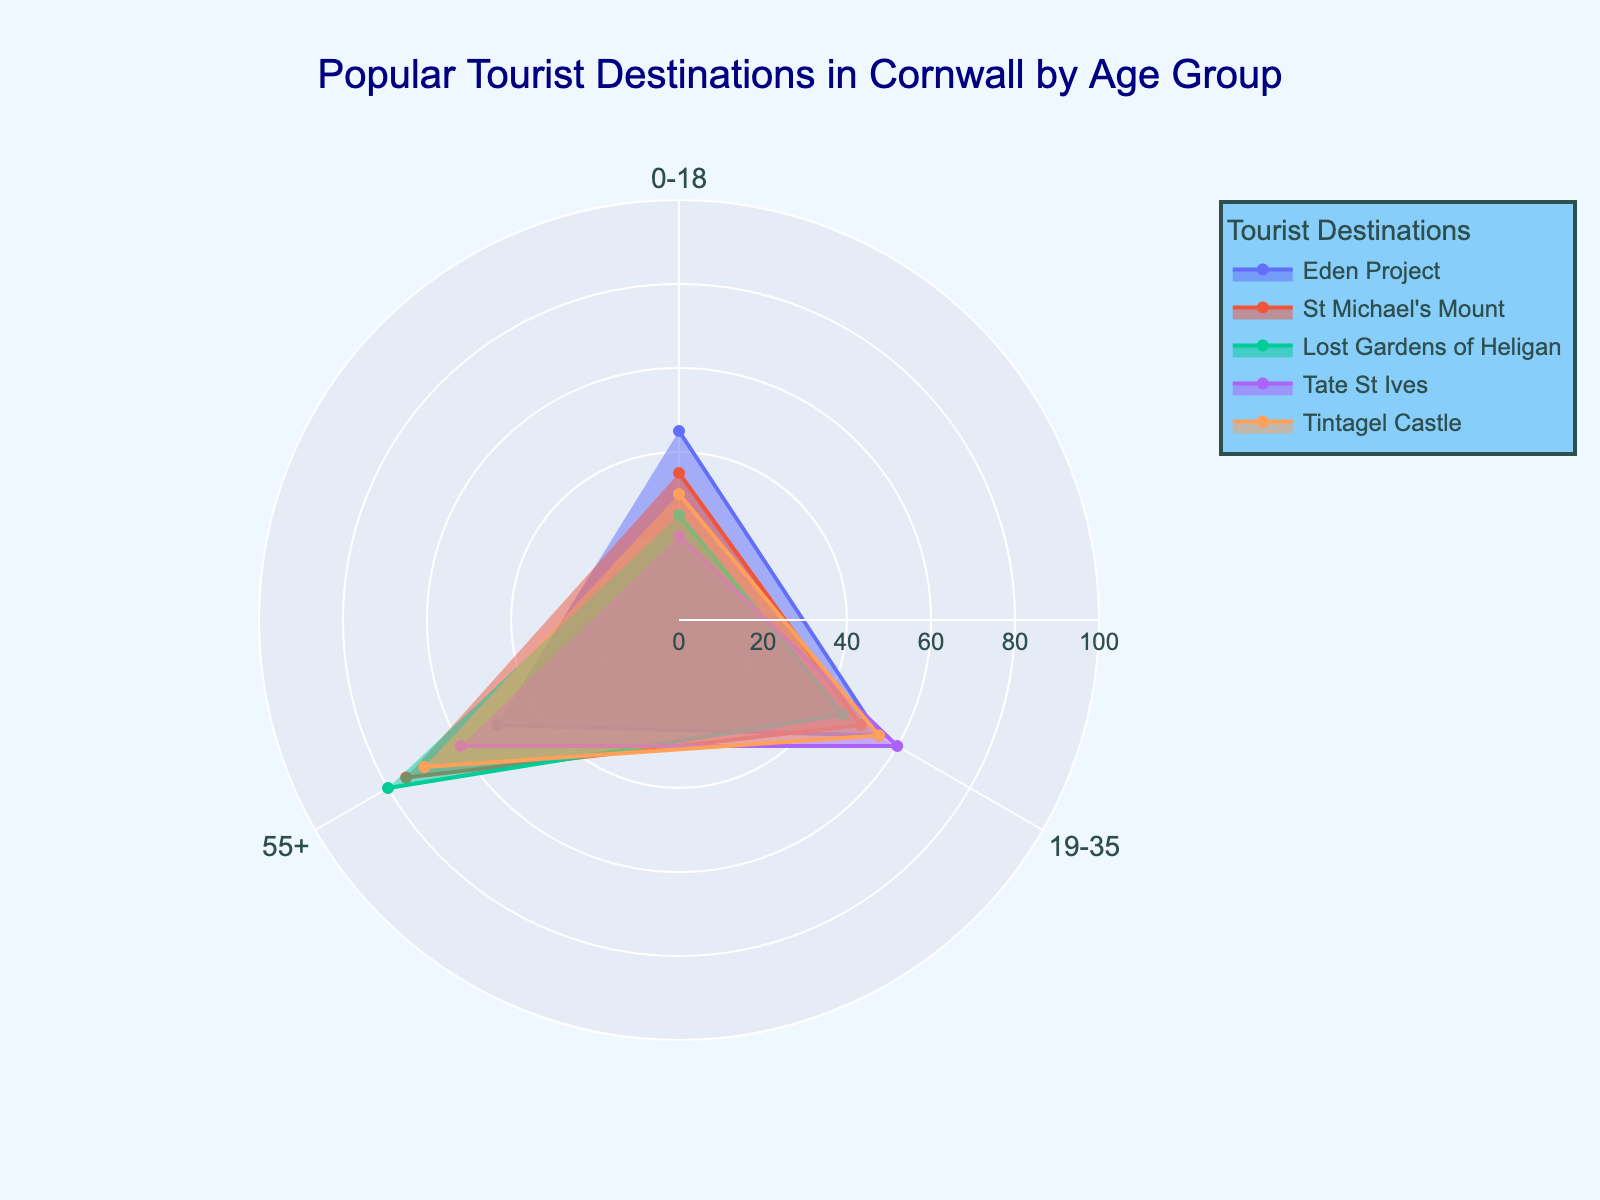Which destination in the '0-18' age group has the highest visitor count? To determine which destination has the highest visitor count in the '0-18' age group, look at the '0-18' section of the radar chart and compare the lengths of the lines representing each destination. The Eden Project has the longest segment in the '0-18' category.
Answer: Eden Project Which destination in the '55+' age group is the least popular? To find the least popular destination in the '55+' age group, observe the '55+' section of the radar chart and identify the shortest segment. The shortest segment in this category represents the Eden Project.
Answer: Eden Project Which age group shows the highest interest in St Michael's Mount? For St Michael's Mount, follow its line segments to each of the three age groups: '0-18', '19-35', and '55+'. The '55+' age group shows the highest interest as indicated by the longest line segment for St Michael's Mount in that section.
Answer: 55+ What is the average visitor count for Tintagel Castle across the age groups shown? For Tintagel Castle, check the values in the '0-18', '19-35', and '55+' age groups and calculate the average: (30 + 55 + 70)/3 = 51.67.
Answer: 51.67 Which destination has the most balanced visitor count across all age groups? To determine the most balanced visitor count, compare the lengths of the line segments for each destination across the three age groups. Tate St Ives has relatively uniform segments across '0-18', '19-35', and '55+' age groups compared to the others.
Answer: Tate St Ives Order the destinations by popularity for the '19-35' age group, from most to least popular. Look at the '19-35' age group lines and compare their lengths for each destination: Tate St Ives (60), Eden Project (55), Tintagel Castle (55), St Michael's Mount (50), and Lost Gardens of Heligan (45). The order is: Tate St Ives, Eden Project/Tintagel Castle, St Michael's Mount, Lost Gardens of Heligan.
Answer: Tate St Ives, Eden Project/Tintagel Castle, St Michael's Mount, Lost Gardens of Heligan Which age group has the most significant variation in visitor count? Assess each age group's segments and their differences in length. The '55+' age group shows the most significant variation, ranging from 50 (Eden Project) to 80 (Lost Gardens of Heligan).
Answer: 55+ What is the total visitor count for Lost Gardens of Heligan across the age groups shown? Sum up the visitor counts for Lost Gardens of Heligan in the age groups '0-18', '19-35', and '55+': 25 + 45 + 80 = 150.
Answer: 150 Comparing the 0-18 age group, which destination is more popular: Tintagel Castle or St Michael's Mount? Observe the '0-18' segments for Tintagel Castle and St Michael's Mount. Tintagel Castle has 30 visitors, while St Michael's Mount has 35 visitors, making St Michael's Mount more popular in this age group.
Answer: St Michael's Mount Which destination has the widest range of visitor counts across the selected age groups? To identify the destination with the widest range, calculate the difference between the highest and lowest visitor counts for each destination across the selected age groups. St Michael's Mount has the widest range, with counts of 35 (0-18) and 75 (55+), giving a range of 40.
Answer: St Michael's Mount 